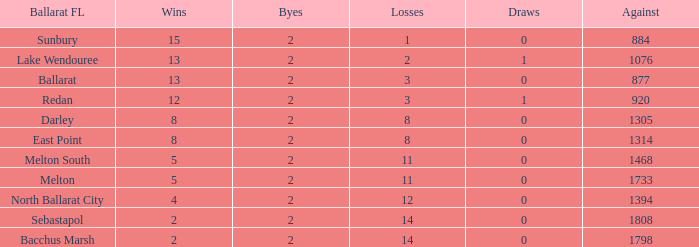How many against is present in a ballarat fl of darley with over 8 wins? 0.0. 